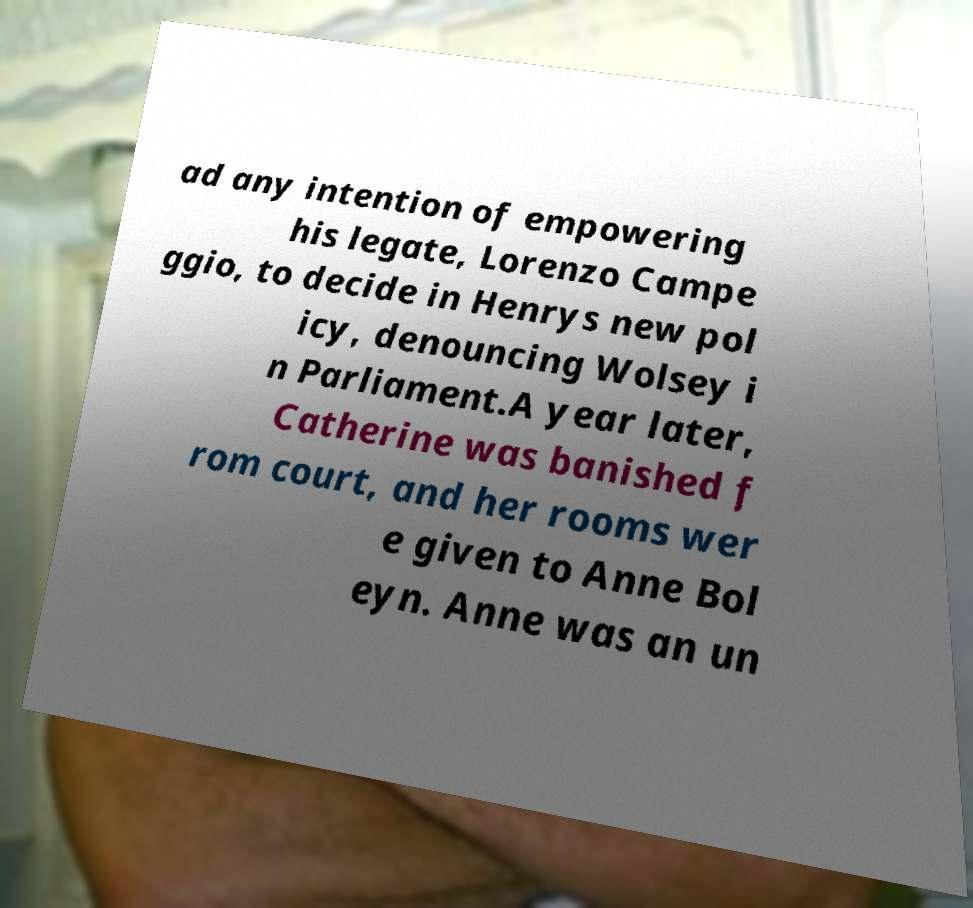Could you extract and type out the text from this image? ad any intention of empowering his legate, Lorenzo Campe ggio, to decide in Henrys new pol icy, denouncing Wolsey i n Parliament.A year later, Catherine was banished f rom court, and her rooms wer e given to Anne Bol eyn. Anne was an un 